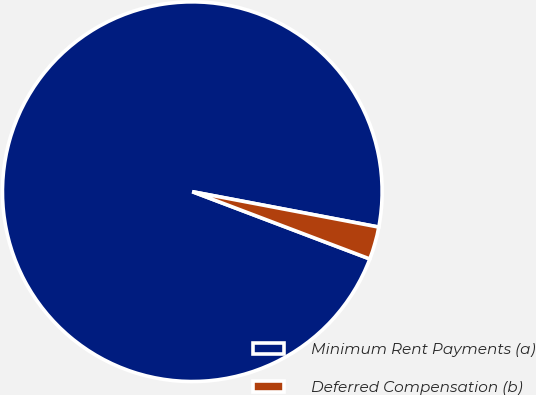Convert chart to OTSL. <chart><loc_0><loc_0><loc_500><loc_500><pie_chart><fcel>Minimum Rent Payments (a)<fcel>Deferred Compensation (b)<nl><fcel>97.22%<fcel>2.78%<nl></chart> 